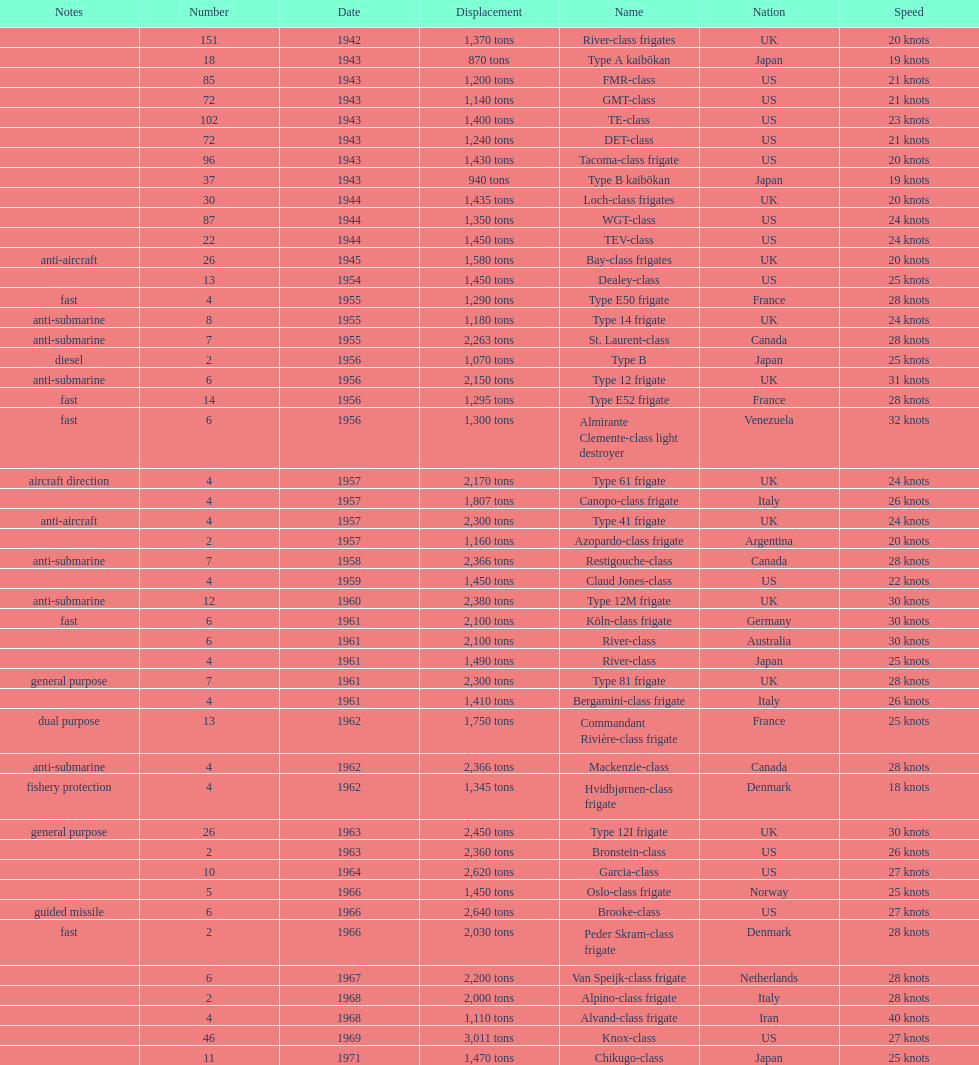Which of the boats listed is the fastest? Alvand-class frigate. 